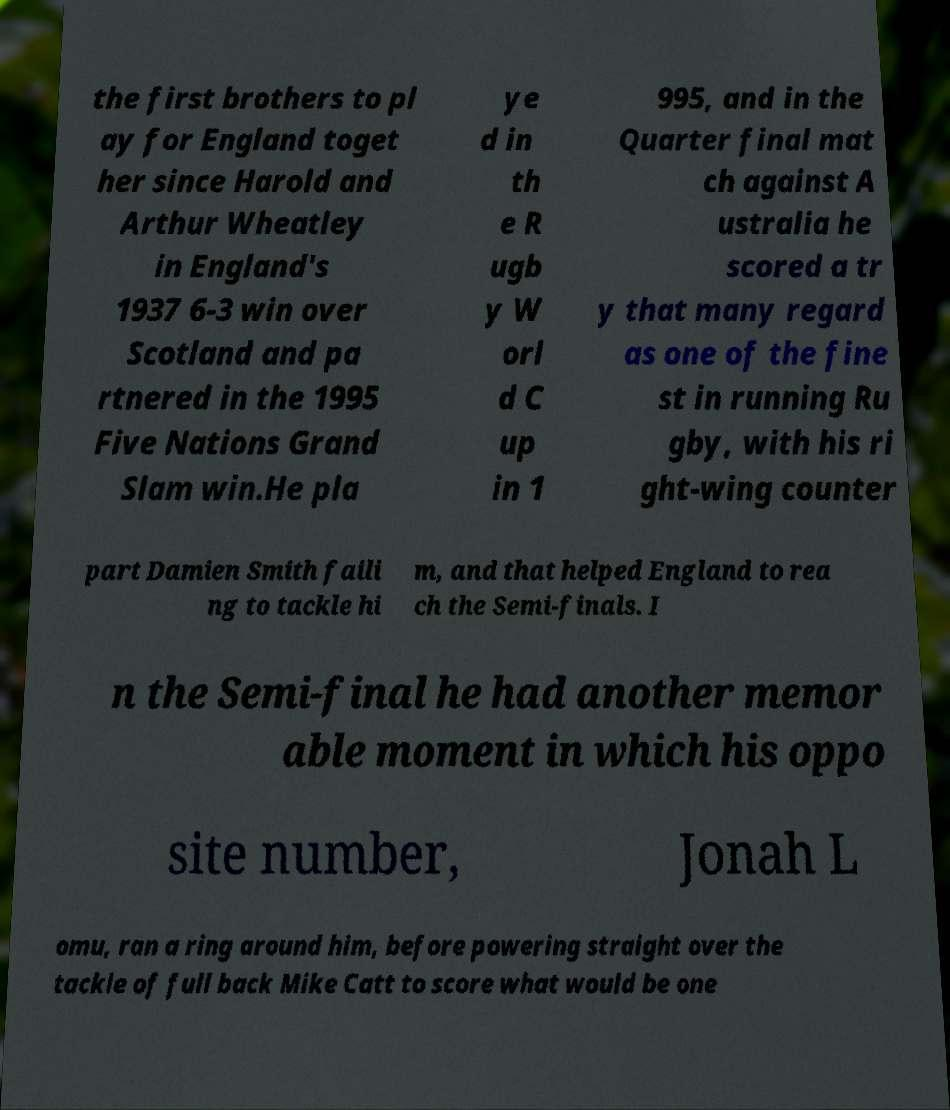I need the written content from this picture converted into text. Can you do that? the first brothers to pl ay for England toget her since Harold and Arthur Wheatley in England's 1937 6-3 win over Scotland and pa rtnered in the 1995 Five Nations Grand Slam win.He pla ye d in th e R ugb y W orl d C up in 1 995, and in the Quarter final mat ch against A ustralia he scored a tr y that many regard as one of the fine st in running Ru gby, with his ri ght-wing counter part Damien Smith faili ng to tackle hi m, and that helped England to rea ch the Semi-finals. I n the Semi-final he had another memor able moment in which his oppo site number, Jonah L omu, ran a ring around him, before powering straight over the tackle of full back Mike Catt to score what would be one 